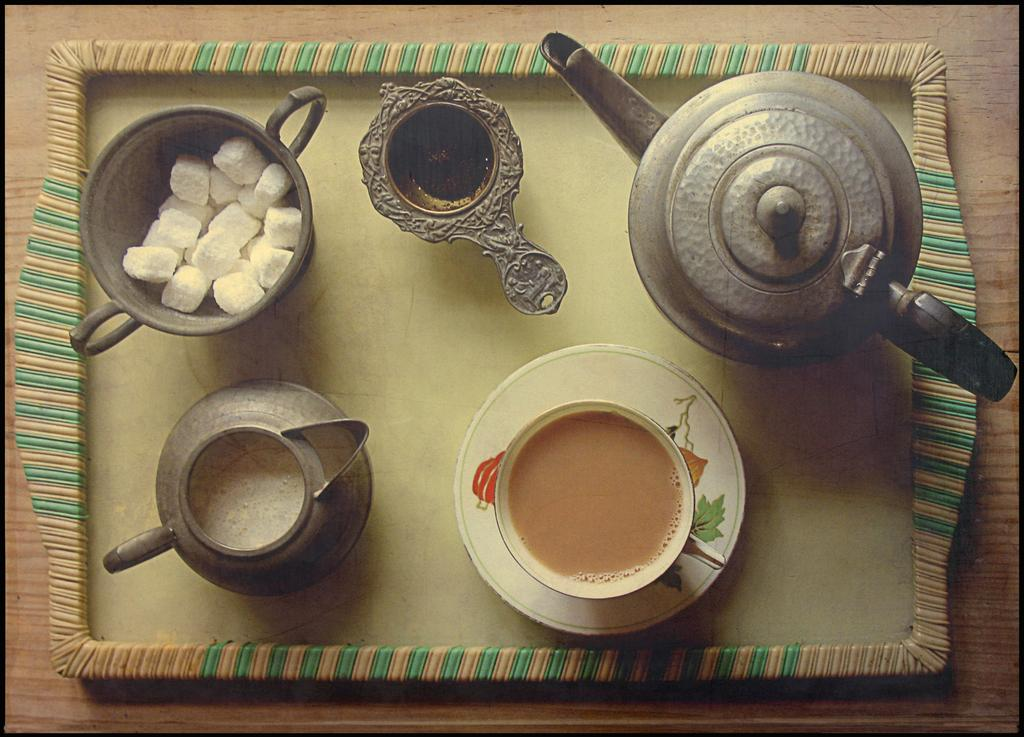What type of dishware is present in the image? There is a group of bowls and a tea cup on a saucer in the image. How are the tea cup and saucer arranged in the image? The tea cup and saucer are placed on a tray in the image. Where is the tray located in the image? The tray is placed on a table in the image. What is the minister reading in the image? There is no minister or reading material present in the image. 